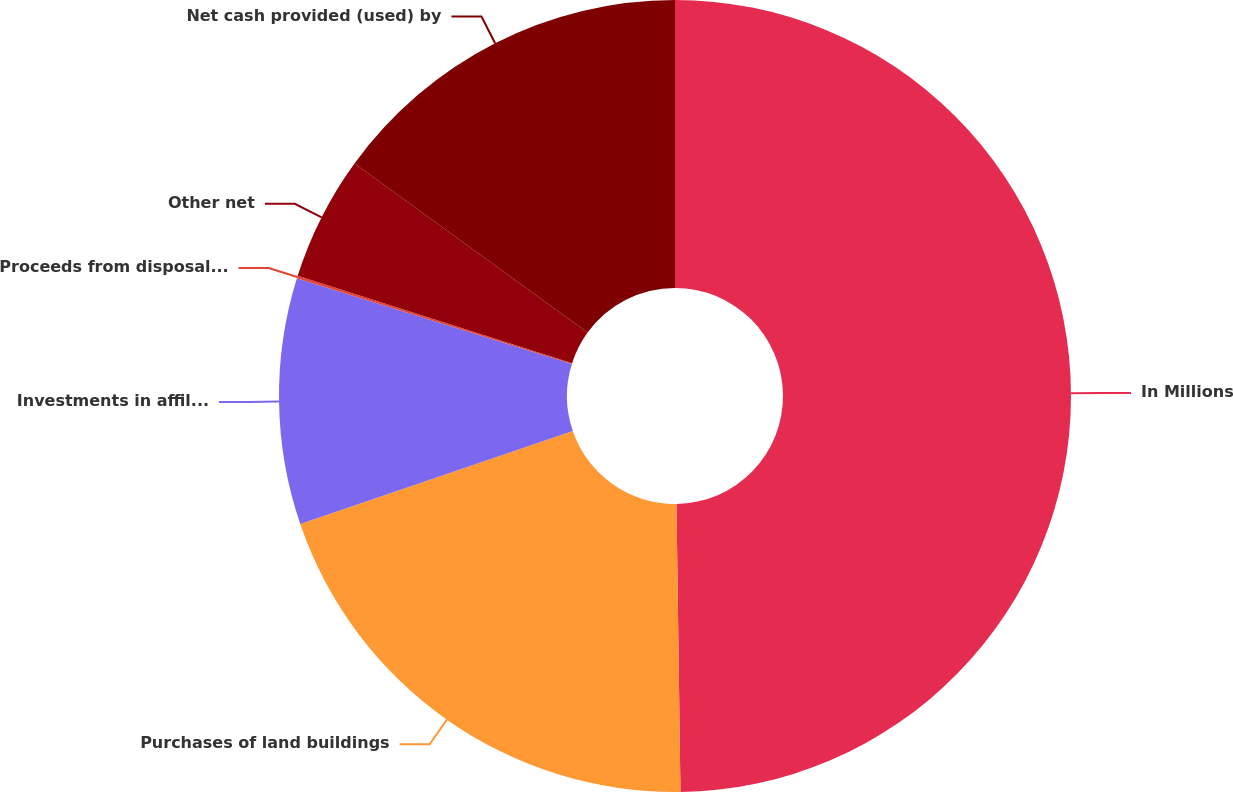<chart> <loc_0><loc_0><loc_500><loc_500><pie_chart><fcel>In Millions<fcel>Purchases of land buildings<fcel>Investments in affiliates net<fcel>Proceeds from disposal of land<fcel>Other net<fcel>Net cash provided (used) by<nl><fcel>49.78%<fcel>19.98%<fcel>10.04%<fcel>0.11%<fcel>5.08%<fcel>15.01%<nl></chart> 